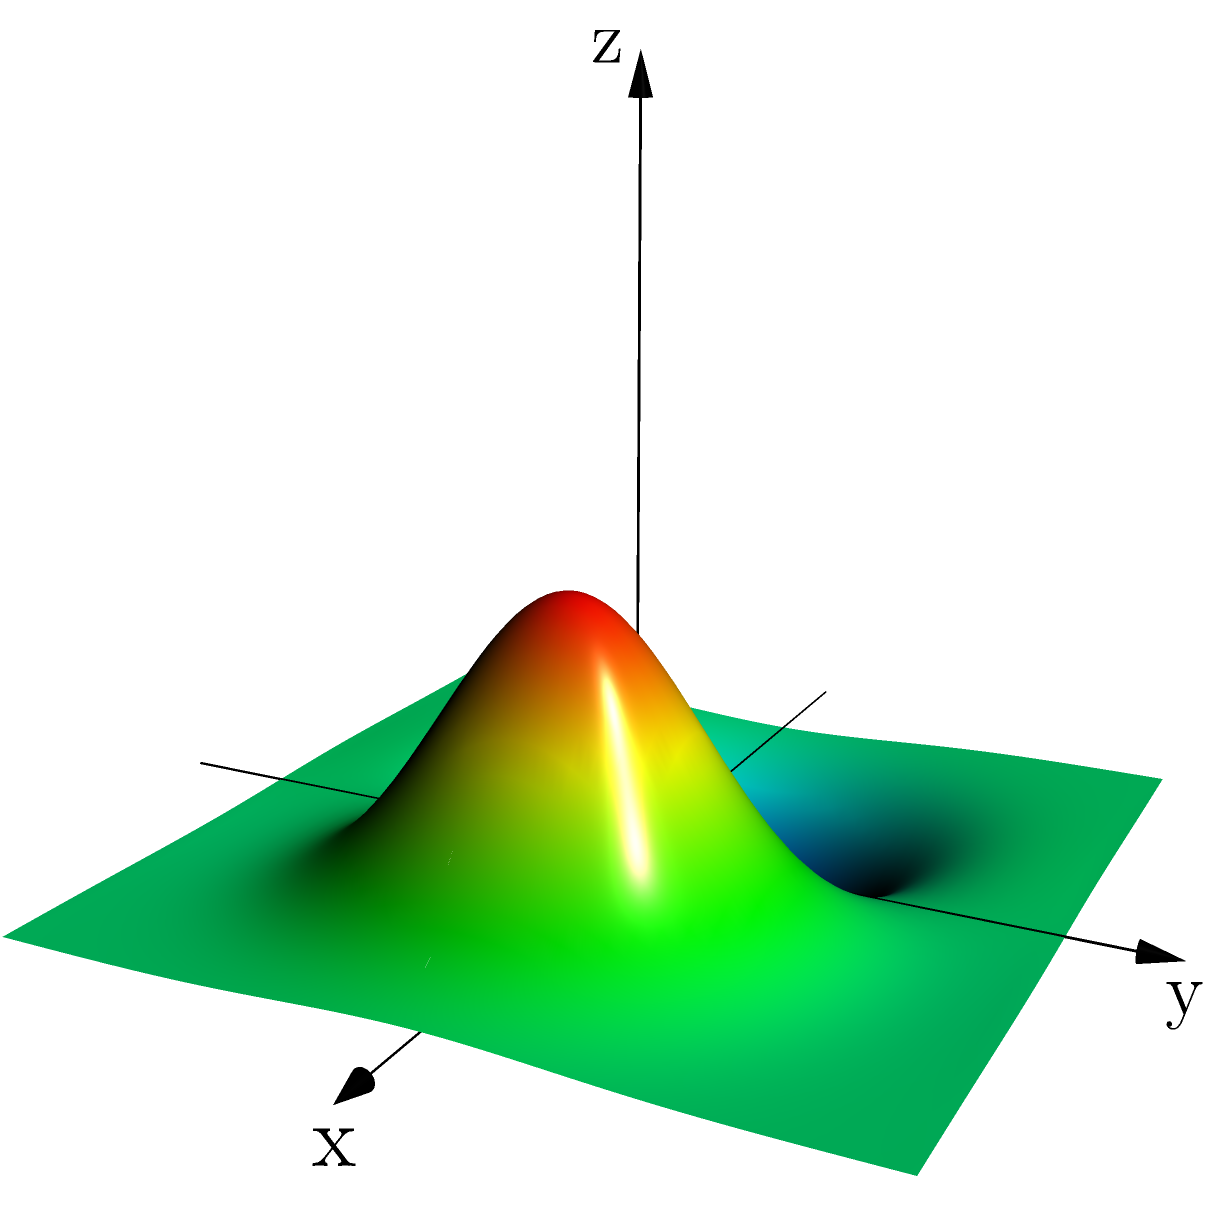Analyze the 3D heat map of a batter's hitting zones. Which area shows the highest probability of successful hits, and how might this information influence defensive positioning? 1. Observe the color gradient: The heat map uses colors to represent hit probability, with warmer colors (red, orange) indicating higher probabilities and cooler colors (blue, green) showing lower probabilities.

2. Identify the peak: The highest point on the map represents the area with the highest hit probability. In this case, it's the red region slightly offset from the center, towards the positive x-axis and slightly towards the positive y-axis.

3. Interpret the axes: The x-axis represents the horizontal position relative to home plate, while the y-axis represents the depth of the hit (distance from home plate). The z-axis shows the probability of a successful hit.

4. Analyze the pattern: The heat map shows a circular pattern with the peak slightly off-center, suggesting the batter tends to hit effectively to a specific area of the field.

5. Consider defensive positioning: Given the concentration of successful hits in this area, the defense might shift towards the right side of the field (from the batter's perspective) and play slightly deeper to cover this hot zone.

6. Strategic implications: Pitchers might avoid throwing to this batter's "sweet spot" and instead target areas with cooler colors on the heat map, where the hit probability is lower.
Answer: Slightly right of center field; shift defense right and deeper 